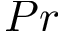Convert formula to latex. <formula><loc_0><loc_0><loc_500><loc_500>P r</formula> 